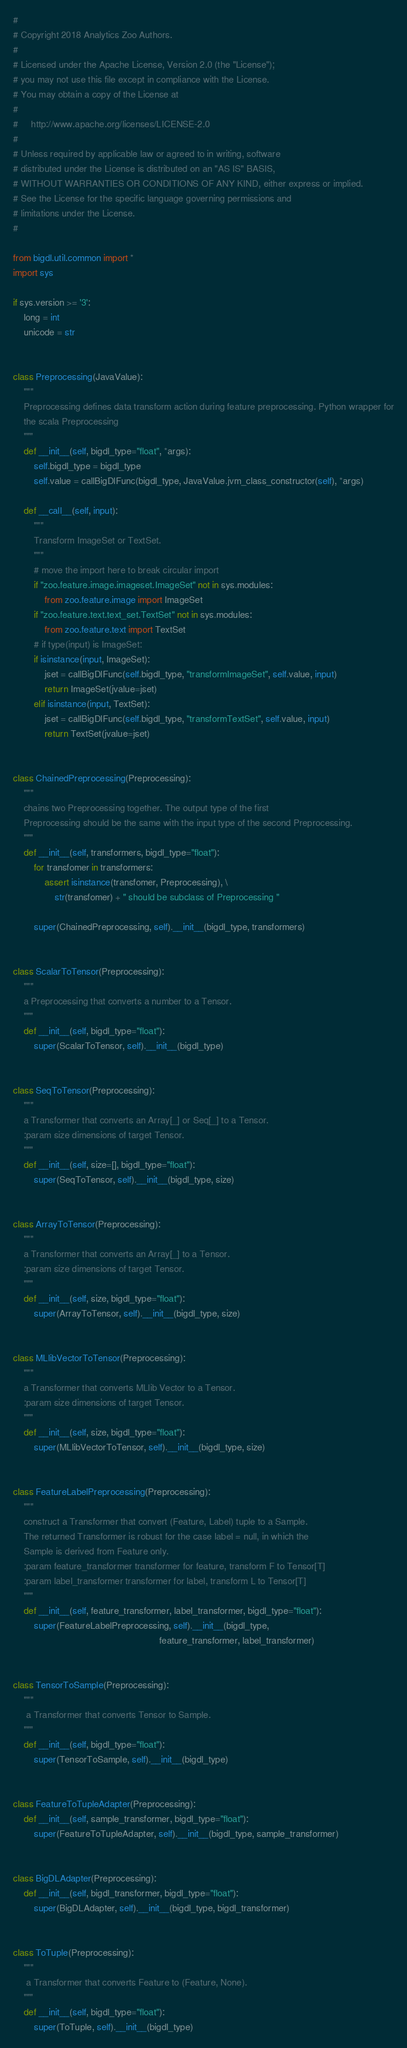Convert code to text. <code><loc_0><loc_0><loc_500><loc_500><_Python_>#
# Copyright 2018 Analytics Zoo Authors.
#
# Licensed under the Apache License, Version 2.0 (the "License");
# you may not use this file except in compliance with the License.
# You may obtain a copy of the License at
#
#     http://www.apache.org/licenses/LICENSE-2.0
#
# Unless required by applicable law or agreed to in writing, software
# distributed under the License is distributed on an "AS IS" BASIS,
# WITHOUT WARRANTIES OR CONDITIONS OF ANY KIND, either express or implied.
# See the License for the specific language governing permissions and
# limitations under the License.
#

from bigdl.util.common import *
import sys

if sys.version >= '3':
    long = int
    unicode = str


class Preprocessing(JavaValue):
    """
    Preprocessing defines data transform action during feature preprocessing. Python wrapper for
    the scala Preprocessing
    """
    def __init__(self, bigdl_type="float", *args):
        self.bigdl_type = bigdl_type
        self.value = callBigDlFunc(bigdl_type, JavaValue.jvm_class_constructor(self), *args)

    def __call__(self, input):
        """
        Transform ImageSet or TextSet.
        """
        # move the import here to break circular import
        if "zoo.feature.image.imageset.ImageSet" not in sys.modules:
            from zoo.feature.image import ImageSet
        if "zoo.feature.text.text_set.TextSet" not in sys.modules:
            from zoo.feature.text import TextSet
        # if type(input) is ImageSet:
        if isinstance(input, ImageSet):
            jset = callBigDlFunc(self.bigdl_type, "transformImageSet", self.value, input)
            return ImageSet(jvalue=jset)
        elif isinstance(input, TextSet):
            jset = callBigDlFunc(self.bigdl_type, "transformTextSet", self.value, input)
            return TextSet(jvalue=jset)


class ChainedPreprocessing(Preprocessing):
    """
    chains two Preprocessing together. The output type of the first
    Preprocessing should be the same with the input type of the second Preprocessing.
    """
    def __init__(self, transformers, bigdl_type="float"):
        for transfomer in transformers:
            assert isinstance(transfomer, Preprocessing), \
                str(transfomer) + " should be subclass of Preprocessing "

        super(ChainedPreprocessing, self).__init__(bigdl_type, transformers)


class ScalarToTensor(Preprocessing):
    """
    a Preprocessing that converts a number to a Tensor.
    """
    def __init__(self, bigdl_type="float"):
        super(ScalarToTensor, self).__init__(bigdl_type)


class SeqToTensor(Preprocessing):
    """
    a Transformer that converts an Array[_] or Seq[_] to a Tensor.
    :param size dimensions of target Tensor.
    """
    def __init__(self, size=[], bigdl_type="float"):
        super(SeqToTensor, self).__init__(bigdl_type, size)


class ArrayToTensor(Preprocessing):
    """
    a Transformer that converts an Array[_] to a Tensor.
    :param size dimensions of target Tensor.
    """
    def __init__(self, size, bigdl_type="float"):
        super(ArrayToTensor, self).__init__(bigdl_type, size)


class MLlibVectorToTensor(Preprocessing):
    """
    a Transformer that converts MLlib Vector to a Tensor.
    :param size dimensions of target Tensor.
    """
    def __init__(self, size, bigdl_type="float"):
        super(MLlibVectorToTensor, self).__init__(bigdl_type, size)


class FeatureLabelPreprocessing(Preprocessing):
    """
    construct a Transformer that convert (Feature, Label) tuple to a Sample.
    The returned Transformer is robust for the case label = null, in which the
    Sample is derived from Feature only.
    :param feature_transformer transformer for feature, transform F to Tensor[T]
    :param label_transformer transformer for label, transform L to Tensor[T]
    """
    def __init__(self, feature_transformer, label_transformer, bigdl_type="float"):
        super(FeatureLabelPreprocessing, self).__init__(bigdl_type,
                                                        feature_transformer, label_transformer)


class TensorToSample(Preprocessing):
    """
     a Transformer that converts Tensor to Sample.
    """
    def __init__(self, bigdl_type="float"):
        super(TensorToSample, self).__init__(bigdl_type)


class FeatureToTupleAdapter(Preprocessing):
    def __init__(self, sample_transformer, bigdl_type="float"):
        super(FeatureToTupleAdapter, self).__init__(bigdl_type, sample_transformer)


class BigDLAdapter(Preprocessing):
    def __init__(self, bigdl_transformer, bigdl_type="float"):
        super(BigDLAdapter, self).__init__(bigdl_type, bigdl_transformer)


class ToTuple(Preprocessing):
    """
     a Transformer that converts Feature to (Feature, None).
    """
    def __init__(self, bigdl_type="float"):
        super(ToTuple, self).__init__(bigdl_type)
</code> 